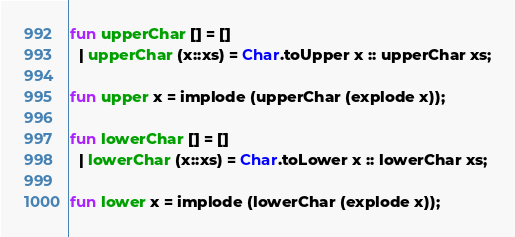<code> <loc_0><loc_0><loc_500><loc_500><_SML_>fun upperChar [] = []
  | upperChar (x::xs) = Char.toUpper x :: upperChar xs;

fun upper x = implode (upperChar (explode x));

fun lowerChar [] = []
  | lowerChar (x::xs) = Char.toLower x :: lowerChar xs;

fun lower x = implode (lowerChar (explode x));
</code> 